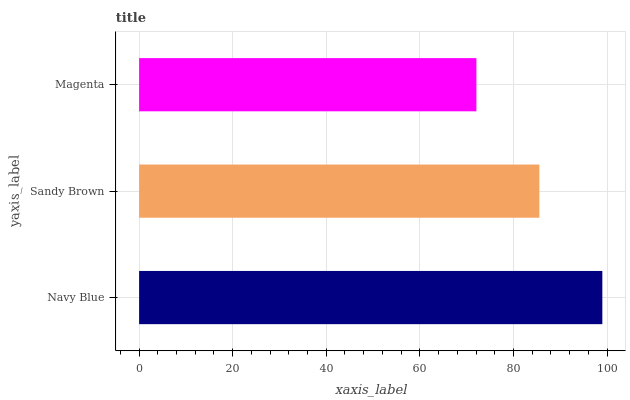Is Magenta the minimum?
Answer yes or no. Yes. Is Navy Blue the maximum?
Answer yes or no. Yes. Is Sandy Brown the minimum?
Answer yes or no. No. Is Sandy Brown the maximum?
Answer yes or no. No. Is Navy Blue greater than Sandy Brown?
Answer yes or no. Yes. Is Sandy Brown less than Navy Blue?
Answer yes or no. Yes. Is Sandy Brown greater than Navy Blue?
Answer yes or no. No. Is Navy Blue less than Sandy Brown?
Answer yes or no. No. Is Sandy Brown the high median?
Answer yes or no. Yes. Is Sandy Brown the low median?
Answer yes or no. Yes. Is Magenta the high median?
Answer yes or no. No. Is Navy Blue the low median?
Answer yes or no. No. 